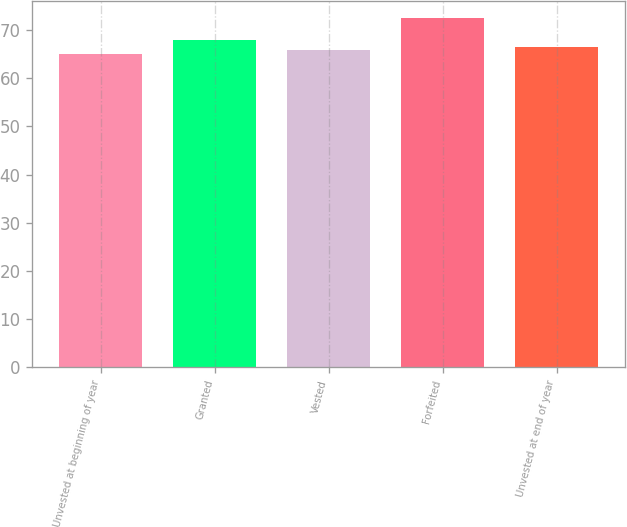<chart> <loc_0><loc_0><loc_500><loc_500><bar_chart><fcel>Unvested at beginning of year<fcel>Granted<fcel>Vested<fcel>Forfeited<fcel>Unvested at end of year<nl><fcel>65.14<fcel>68.04<fcel>65.87<fcel>72.44<fcel>66.6<nl></chart> 